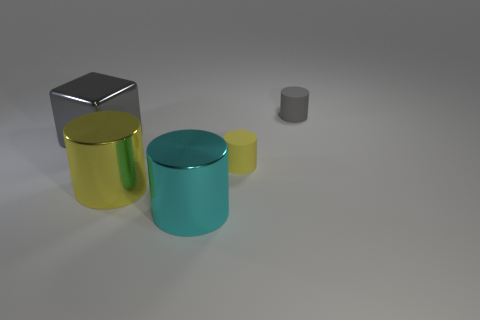Is there a light source in the image, and how does it affect the objects? There is an implied light source in the image off to the side, as indicated by the highlights and shadows present on the objects. The light source gives the objects dimensionality and helps to distinguish their shapes and textures. The reflections on the yellow and blue cylinders particularly emphasize their cylindrical shape and shiny surface. 